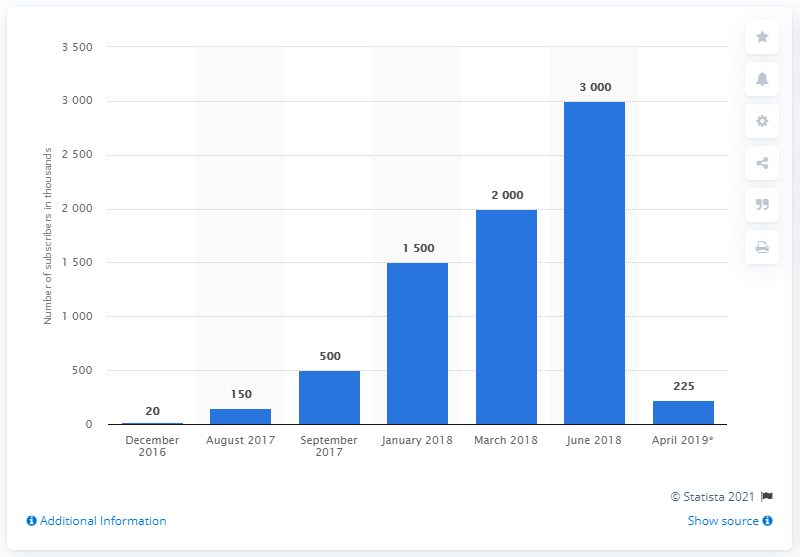Identify some key points in this picture. In June 2018, MoviePass reached three million subscribers. As of April 2019, MoviePass had approximately 225 subscribers. 